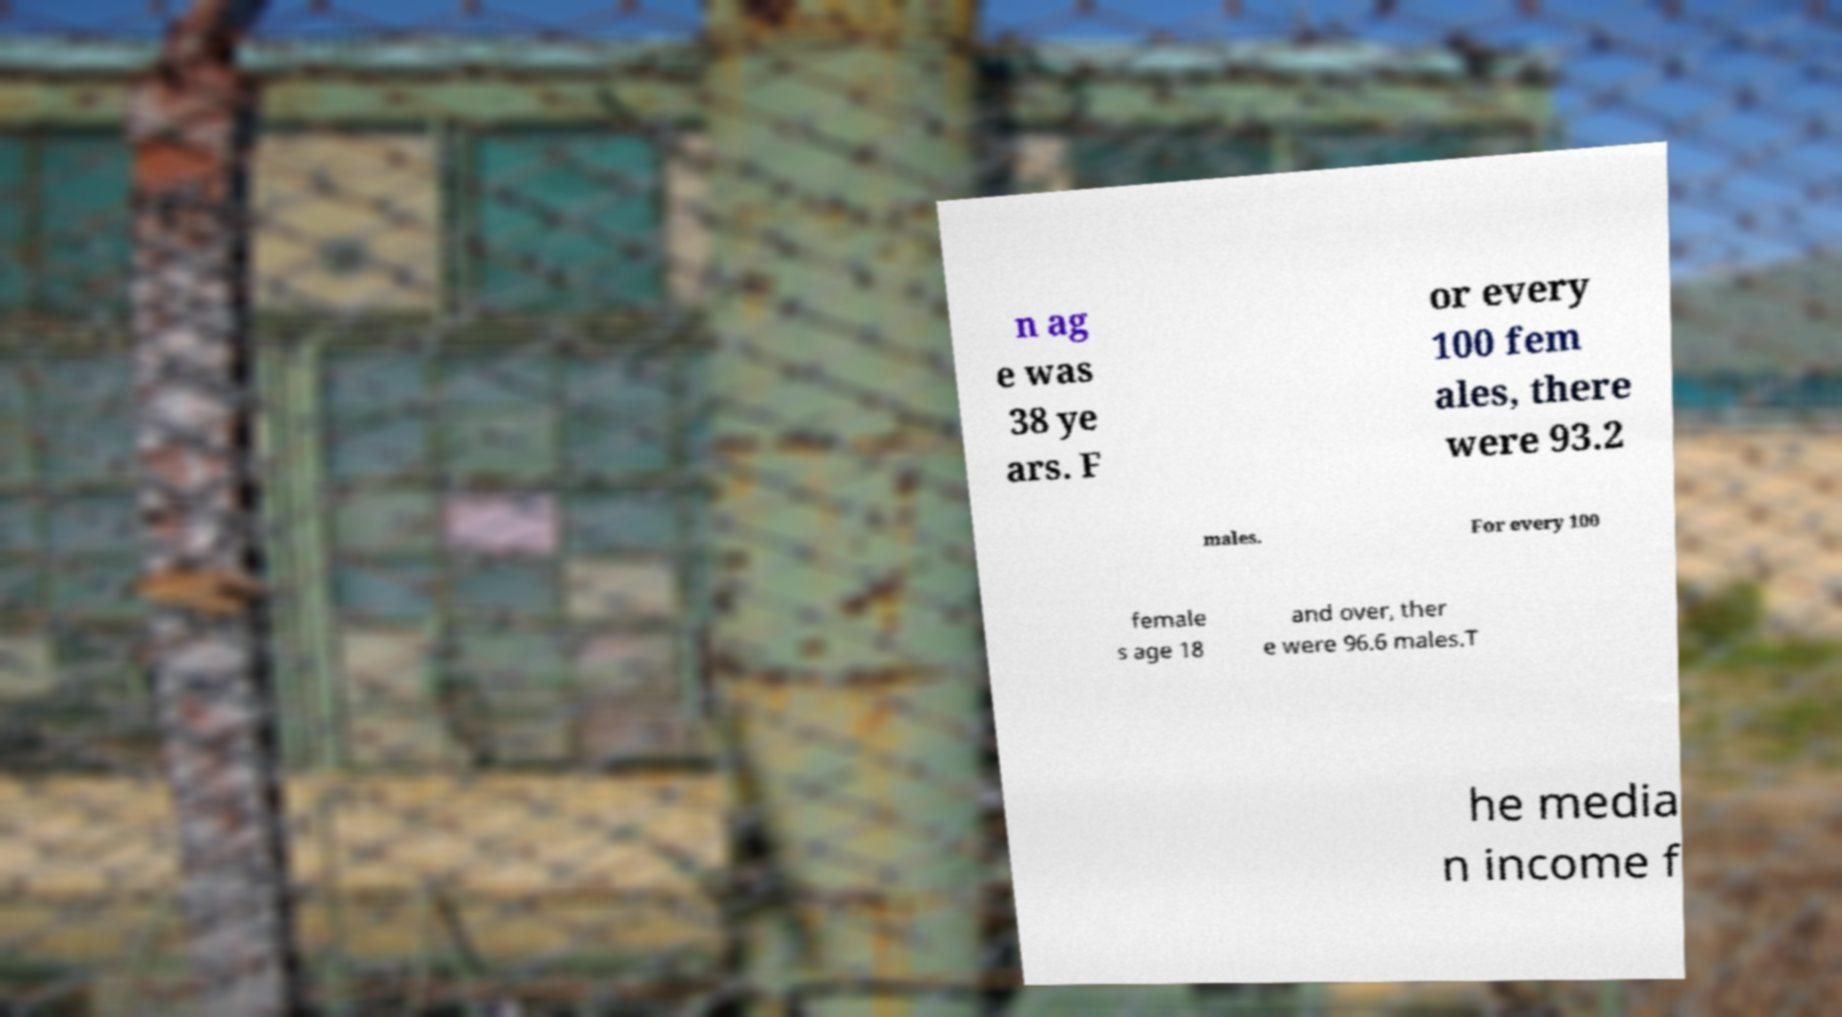Could you extract and type out the text from this image? n ag e was 38 ye ars. F or every 100 fem ales, there were 93.2 males. For every 100 female s age 18 and over, ther e were 96.6 males.T he media n income f 